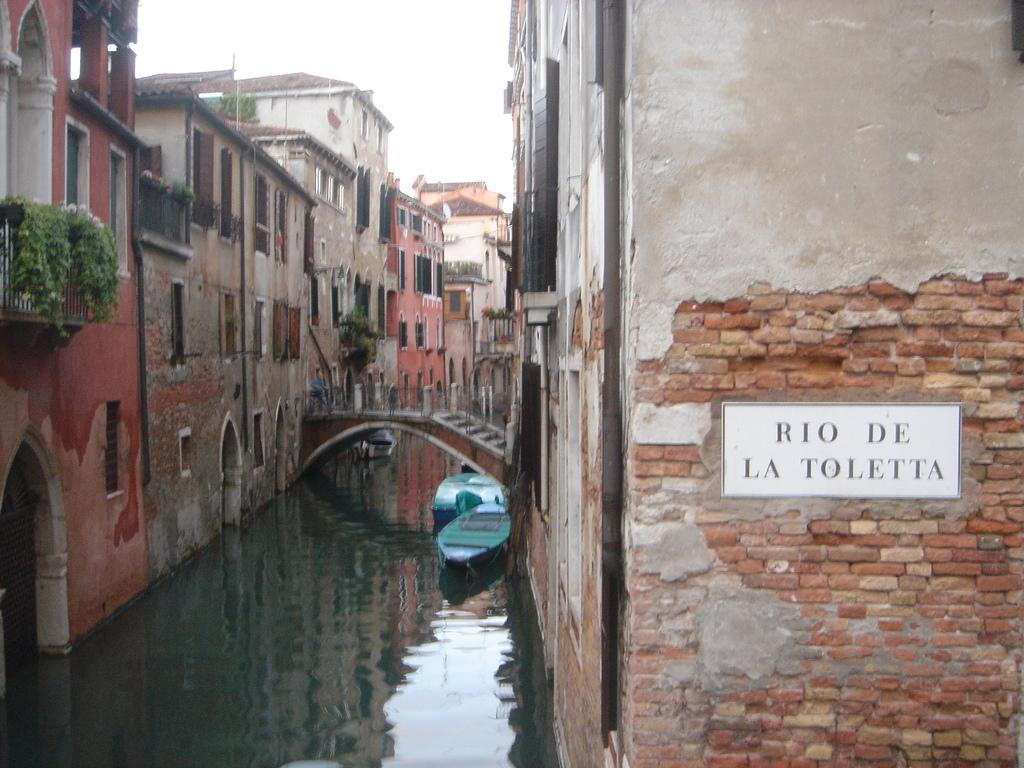Can you describe this image briefly? In this image we can see a board to brick wall, boats floating on the water, bridge, houses and the the sky in the background. 